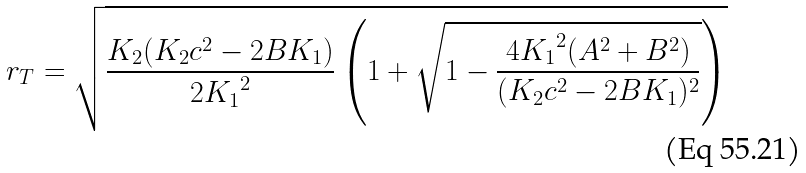Convert formula to latex. <formula><loc_0><loc_0><loc_500><loc_500>r _ { T } = \sqrt { \frac { K _ { 2 } ( K _ { 2 } c ^ { 2 } - 2 B K _ { 1 } ) } { 2 { K _ { 1 } } ^ { 2 } } \left ( 1 + \sqrt { 1 - \frac { 4 { K _ { 1 } } ^ { 2 } ( A ^ { 2 } + B ^ { 2 } ) } { ( K _ { 2 } c ^ { 2 } - 2 B K _ { 1 } ) ^ { 2 } } } \right ) }</formula> 